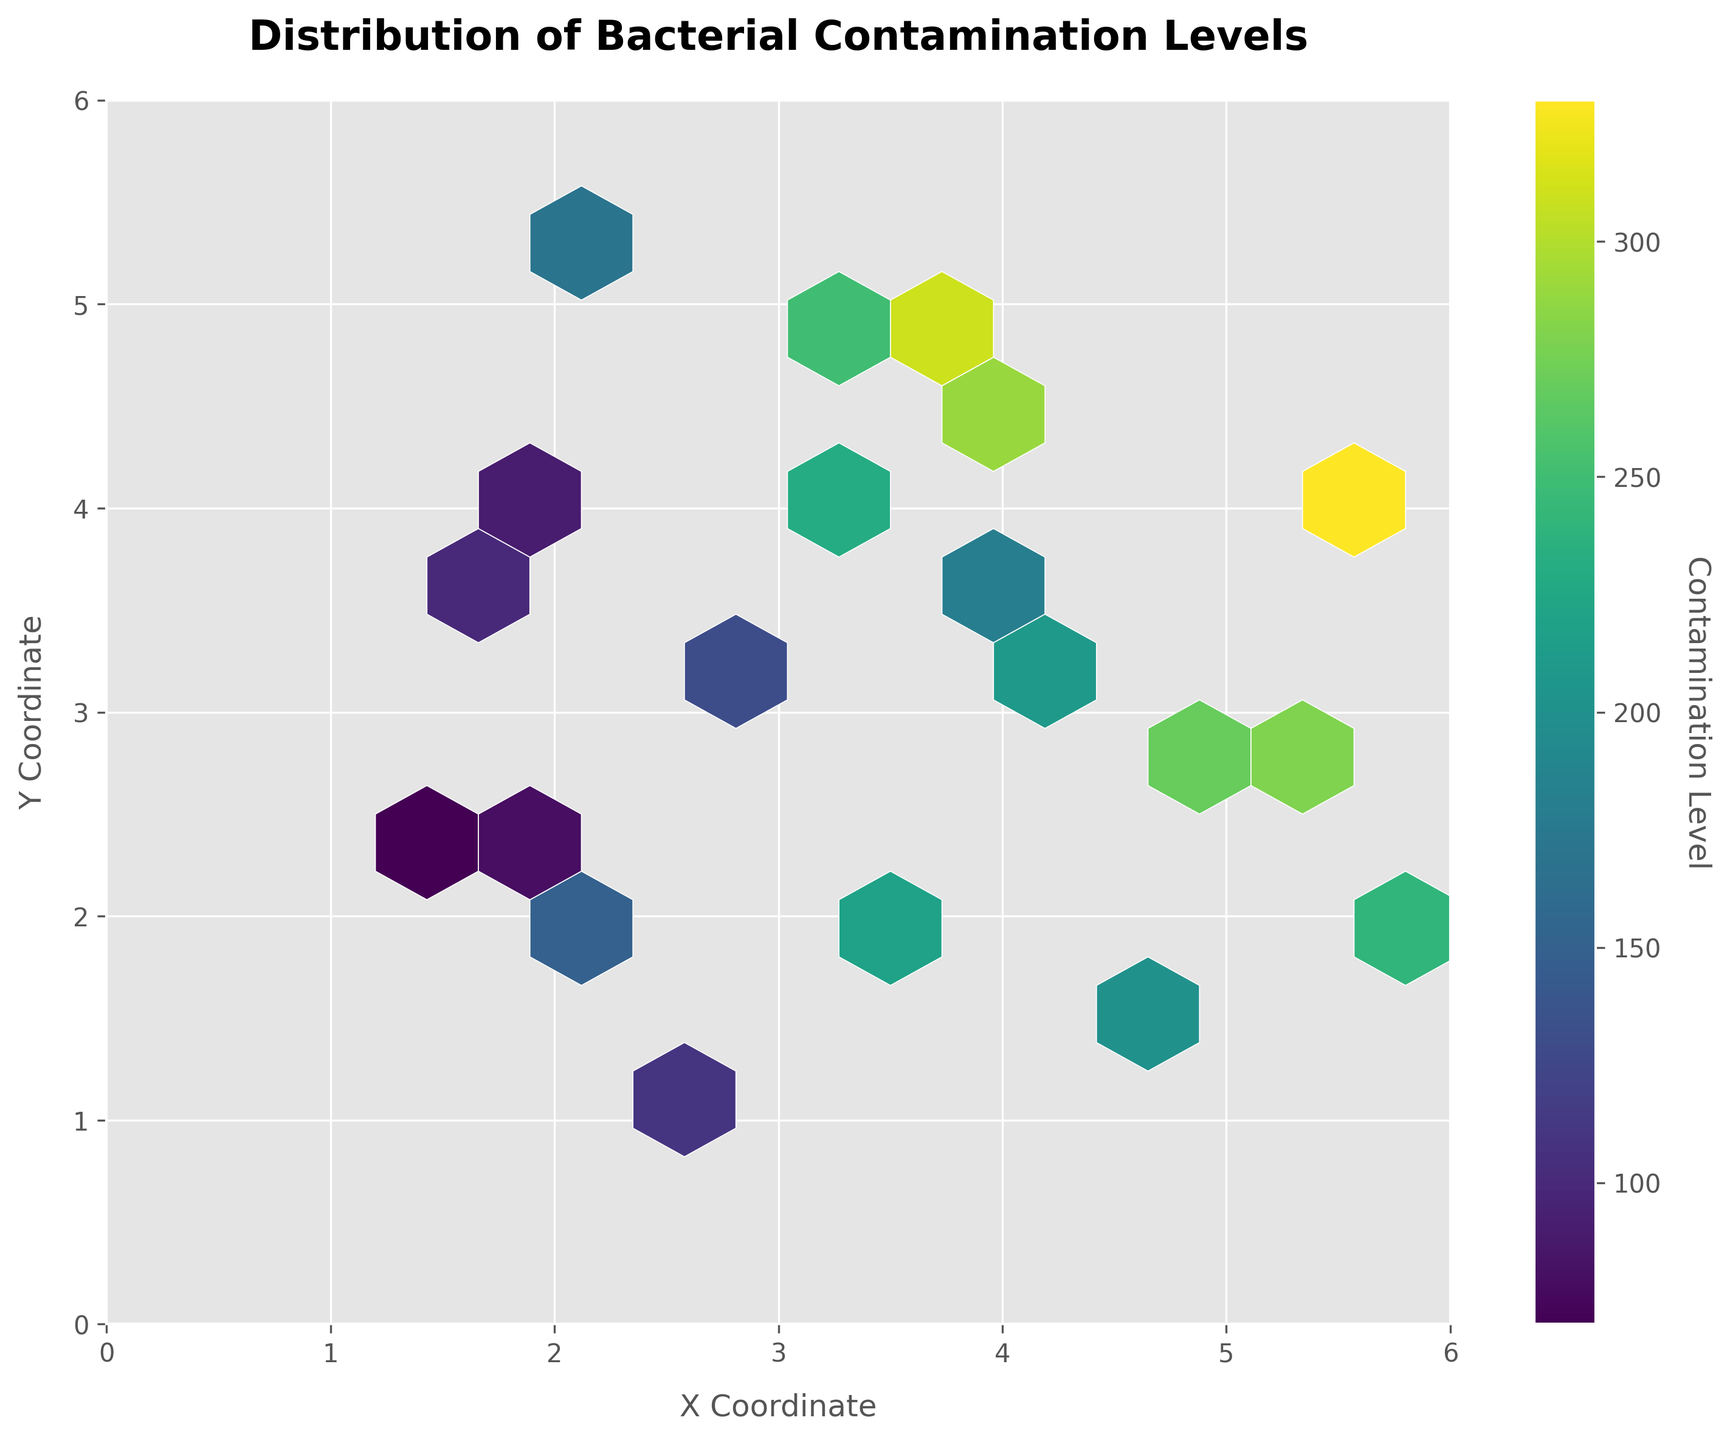What is the title of the figure? The title is typically displayed at the top of the plot. It provides a high-level description of what the plot is about.
Answer: Distribution of Bacterial Contamination Levels What are the axes labels in the figure? The axes labels are displayed along the x and y axes and provide information about the variables being measured.
Answer: X Coordinate (x-axis) and Y Coordinate (y-axis) What is the color scale representing in this hexbin plot? The color scale, shown via the colorbar, indicates the contamination level. Darker colors typically represent higher contamination levels.
Answer: Contamination Level Which area of the plot has the highest contamination level? By comparing the colors in the hexbin plot, the darkest hexbins usually indicate the highest contamination levels. Look for the darkest region.
Answer: Around (5.5, 3.9) How many hexbins have a significantly high contamination level (dark regions)? Count the number of dark-colored hexbins in the plot which suggests higher contamination levels.
Answer: Roughly 2-3 What is the approximate contamination level in the area around coordinates (3.5, 2.1)? Find the location (3.5, 2.1) on the plot and look at the color of the hexbin there. Match it to the colorbar to get the approximate contamination level.
Answer: Around 220 Which region has the least contamination level? The lightest hexbin (light yellow or white) in the plot indicates the least contamination level. Locate this region.
Answer: Around (1.2, 2.5) Compare the contamination level around (2.7, 3.3) and (3.3, 4.1). Which is higher? Locate both coordinates on the plot and compare the colors of the hexbins. The hexbin with the darker color represents the higher contamination level.
Answer: (3.3, 4.1) Is there any clear clustering of higher contamination levels? If so, where does it occur? Look for a grouping of dark-colored hexbins that might indicate a cluster of high contamination levels.
Answer: Yes, around (4.5, 3.9) What can be inferred about the distribution of contamination levels in the food processing facilities from this plot? By analyzing the spread and density of different-colored hexbins, you can infer how contamination levels vary across different areas. Darker clustered regions suggest higher contamination in certain areas.
Answer: Varies, with higher levels in certain clusters 